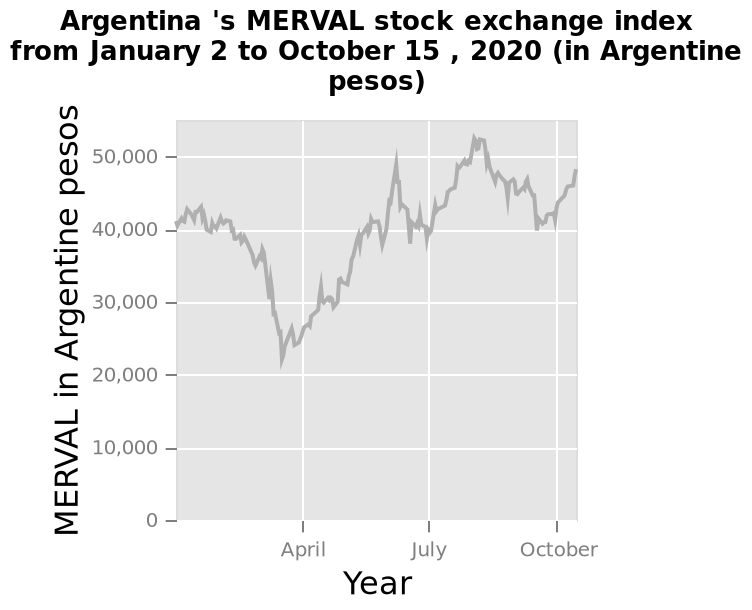<image>
Describe the following image in detail Here a is a line graph titled Argentina 's MERVAL stock exchange index from January 2 to October 15 , 2020 (in Argentine pesos). The y-axis plots MERVAL in Argentine pesos as a linear scale of range 0 to 50,000. Year is measured with a categorical scale with April on one end and October at the other on the x-axis. Offer a thorough analysis of the image. There was a drop in the price of Merval in April which was at it's lowest point of 20,000 pesos. From April onward MErval had a fairly steady increase throughout the summer with a couple of peaks. It dropped back to 40,000 pesos in October and started climbing upward again. At its highest point the price of Merval was over 50,000 pesos. How is the year measured on the x-axis of the graph? The year is measured on the x-axis of the graph using a categorical scale, with April on one end and October at the other. What was the value of the MERVAL in October? The value of the MERVAL in October was just under 50,000. What is the title of the line graph?  The title of the line graph is "Argentina's MERVAL stock exchange index". What is the range of the y-axis on the graph? The range of the y-axis on the graph is 0 to 50,000 Argentine pesos. Was the value of the MERVAL in October just over 50,000? No.The value of the MERVAL in October was just under 50,000. 